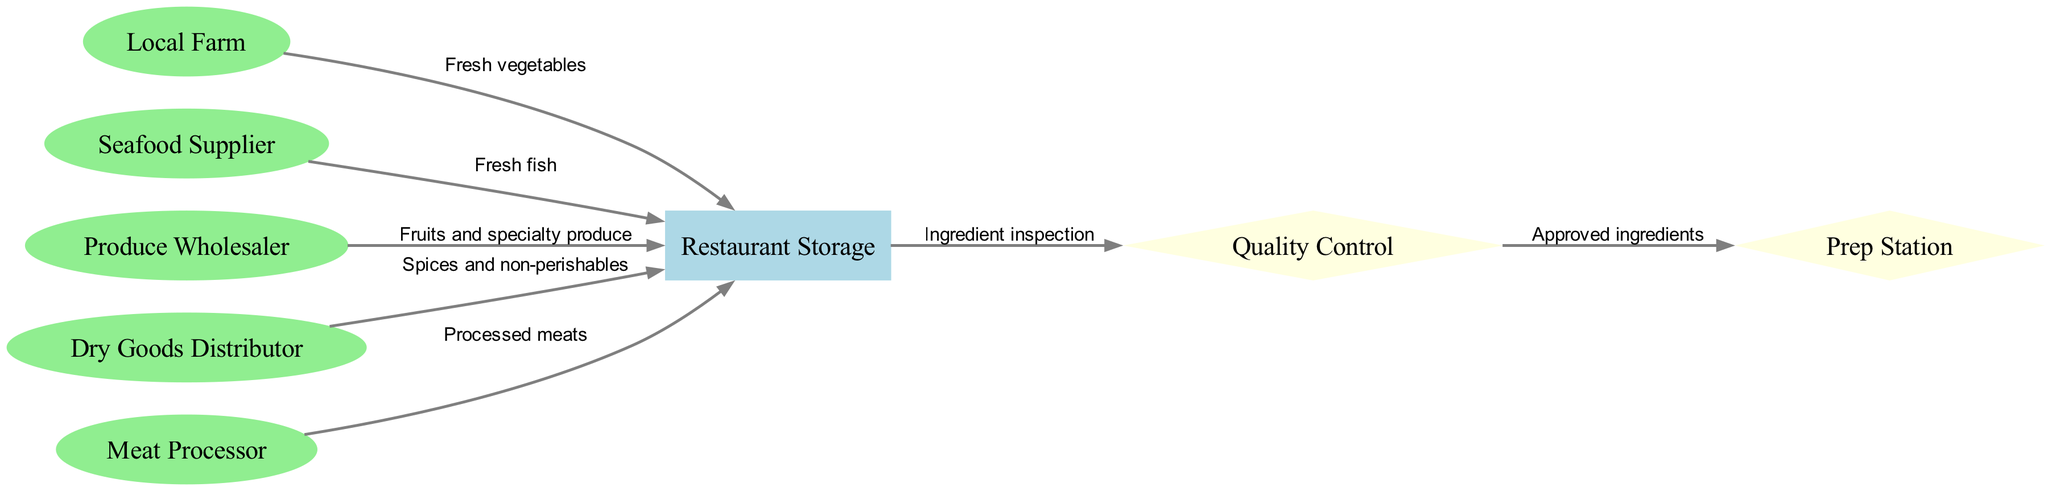What are the main sources of ingredients for the restaurant? The diagram shows three main sources: Local Farm, Seafood Supplier, and Produce Wholesaler, which provide fresh vegetables, fresh fish, and fruits respectively.
Answer: Local Farm, Seafood Supplier, Produce Wholesaler What is the first step in the supply chain for ingredients? The first step is represented by the Local Farm, which supplies fresh vegetables directly to the Restaurant Storage.
Answer: Local Farm How many nodes are there in the diagram? By counting all the distinct nodes in the diagram, we find there are eight nodes: Local Farm, Seafood Supplier, Produce Wholesaler, Restaurant Storage, Dry Goods Distributor, Meat Processor, Quality Control, and Prep Station.
Answer: 8 What ingredient comes from the Meat Processor? Analyzing the edge from Meat Processor to Restaurant Storage, the diagram specifies that processed meats are delivered to the restaurant storage.
Answer: Processed meats Which node inspects the ingredients before they reach the Prep Station? The Quality Control node comes between Restaurant Storage and Prep Station, indicating it is responsible for inspecting the ingredients.
Answer: Quality Control From which node does the Dry Goods Distributor supply ingredients? The diagram indicates that the Dry Goods Distributor sends spices and non-perishables to the Restaurant Storage.
Answer: Restaurant Storage What is the connection between Restaurant Storage and Quality Control? The edge indicates that "Ingredient inspection" occurs from Restaurant Storage to Quality Control, meaning that ingredients are inspected after being stored.
Answer: Ingredient inspection How many types of ingredients are supplied directly to the Restaurant Storage? By examining the edges leading to Restaurant Storage, we can identify five types of ingredients supplied: fresh vegetables, fresh fish, fruits and specialty produce, spices and non-perishables, and processed meats.
Answer: 5 What is the purpose of the Prep Station in the diagram? The Prep Station receives approved ingredients from Quality Control, indicating it is the final step for preparing the ingredients before cooking.
Answer: Prep Station 